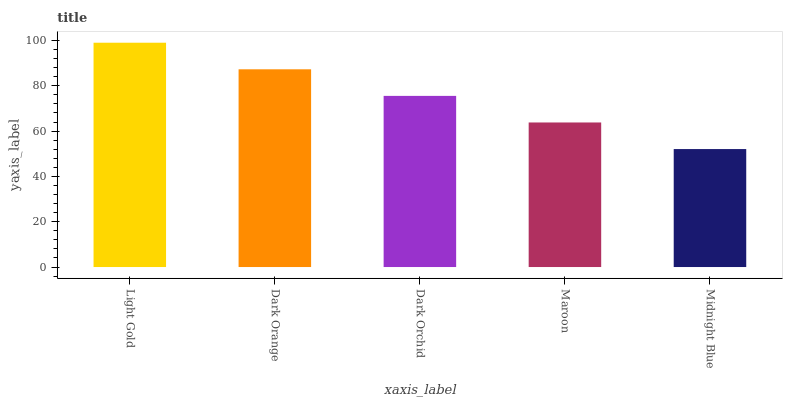Is Midnight Blue the minimum?
Answer yes or no. Yes. Is Light Gold the maximum?
Answer yes or no. Yes. Is Dark Orange the minimum?
Answer yes or no. No. Is Dark Orange the maximum?
Answer yes or no. No. Is Light Gold greater than Dark Orange?
Answer yes or no. Yes. Is Dark Orange less than Light Gold?
Answer yes or no. Yes. Is Dark Orange greater than Light Gold?
Answer yes or no. No. Is Light Gold less than Dark Orange?
Answer yes or no. No. Is Dark Orchid the high median?
Answer yes or no. Yes. Is Dark Orchid the low median?
Answer yes or no. Yes. Is Maroon the high median?
Answer yes or no. No. Is Dark Orange the low median?
Answer yes or no. No. 